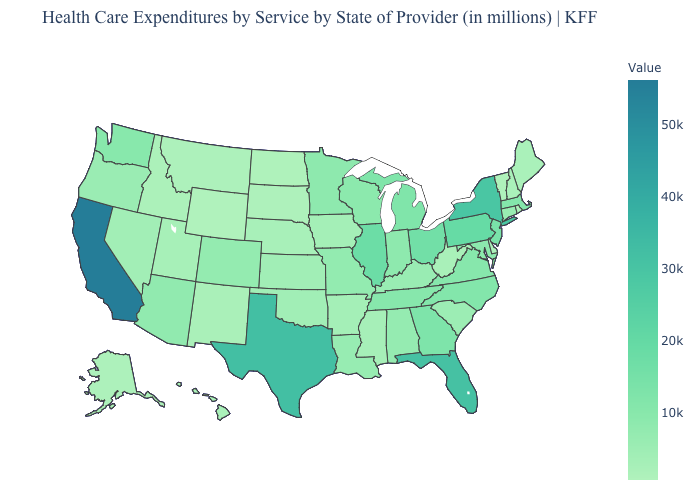Among the states that border Delaware , does Maryland have the lowest value?
Write a very short answer. Yes. Does the map have missing data?
Quick response, please. No. Which states have the lowest value in the West?
Short answer required. Wyoming. Does Wyoming have the lowest value in the USA?
Quick response, please. Yes. 